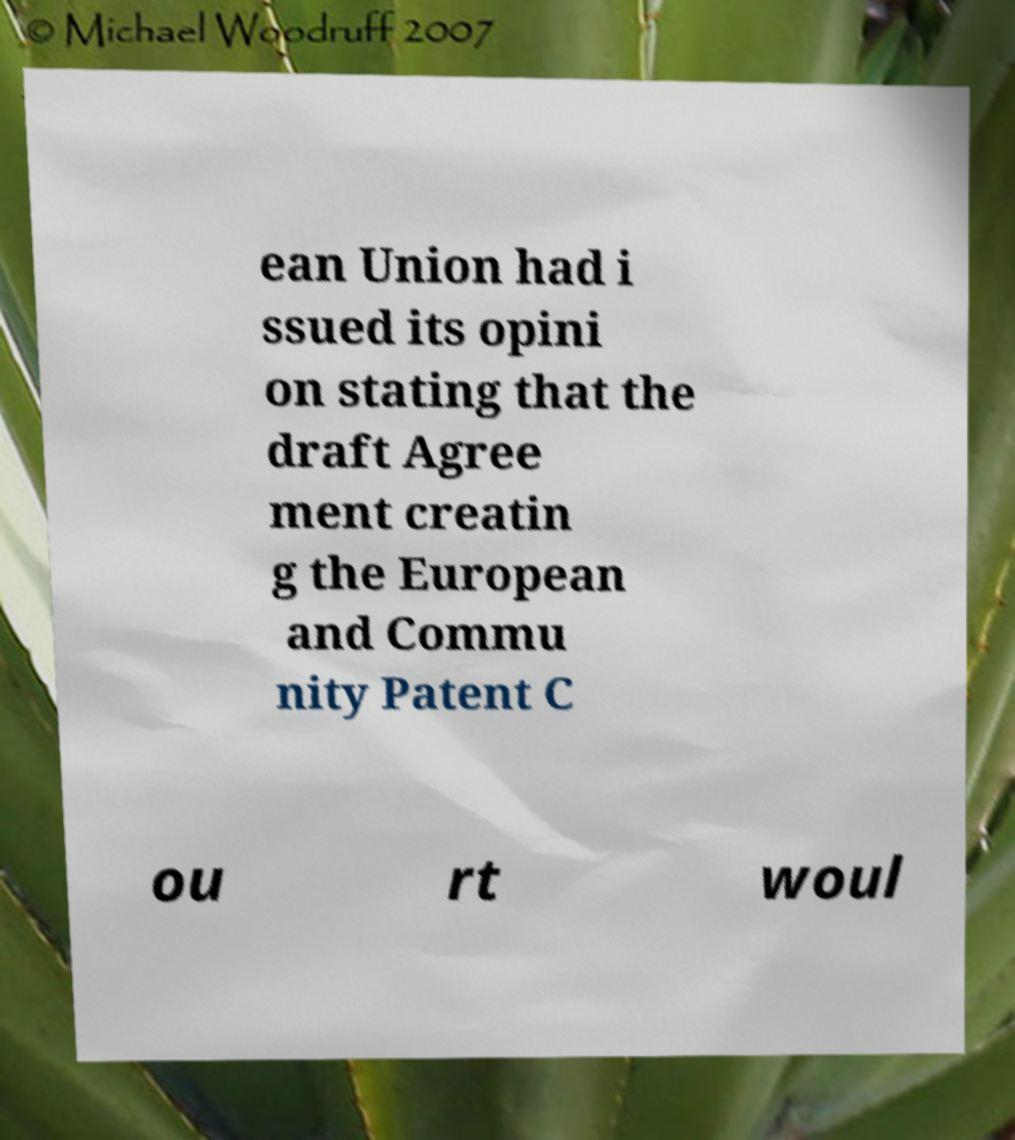I need the written content from this picture converted into text. Can you do that? ean Union had i ssued its opini on stating that the draft Agree ment creatin g the European and Commu nity Patent C ou rt woul 